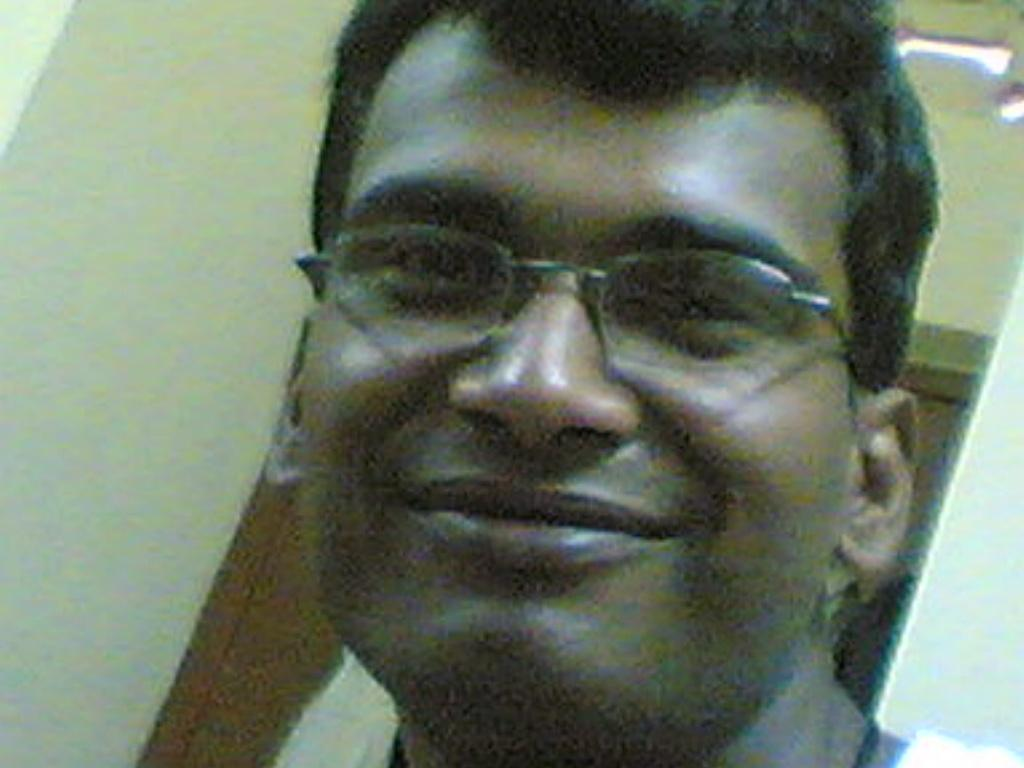What is the main subject of the picture? The main subject of the picture is a man. What is the man's facial expression in the image? The man is smiling in the image. What accessory is the man wearing in the picture? The man is wearing spectacles in the image. Can you describe the background of the image? The background of the image is blurred. What type of humor is the man telling in the image? There is no indication in the image that the man is telling a joke or engaging in any humorous activity. 